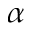<formula> <loc_0><loc_0><loc_500><loc_500>\alpha</formula> 